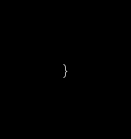<code> <loc_0><loc_0><loc_500><loc_500><_Rust_>}
</code> 